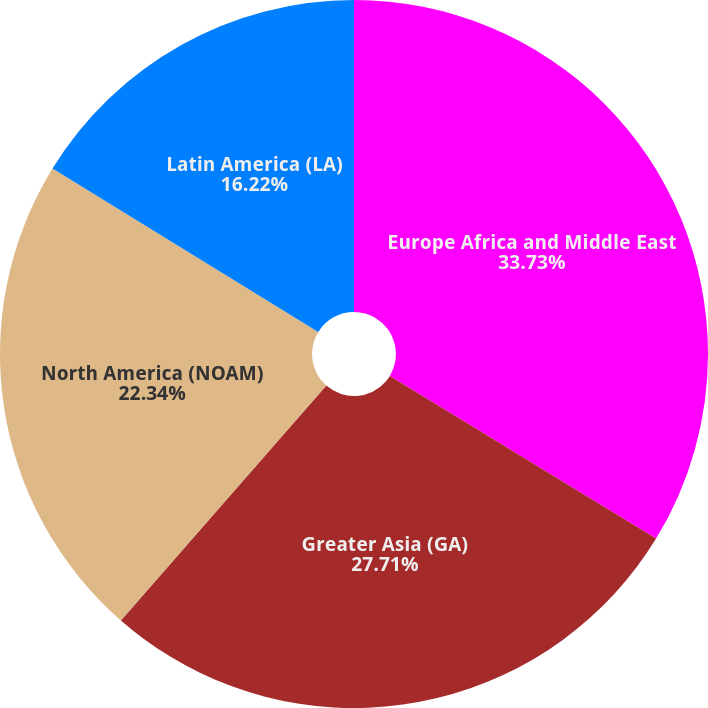Convert chart to OTSL. <chart><loc_0><loc_0><loc_500><loc_500><pie_chart><fcel>Europe Africa and Middle East<fcel>Greater Asia (GA)<fcel>North America (NOAM)<fcel>Latin America (LA)<nl><fcel>33.73%<fcel>27.71%<fcel>22.34%<fcel>16.22%<nl></chart> 